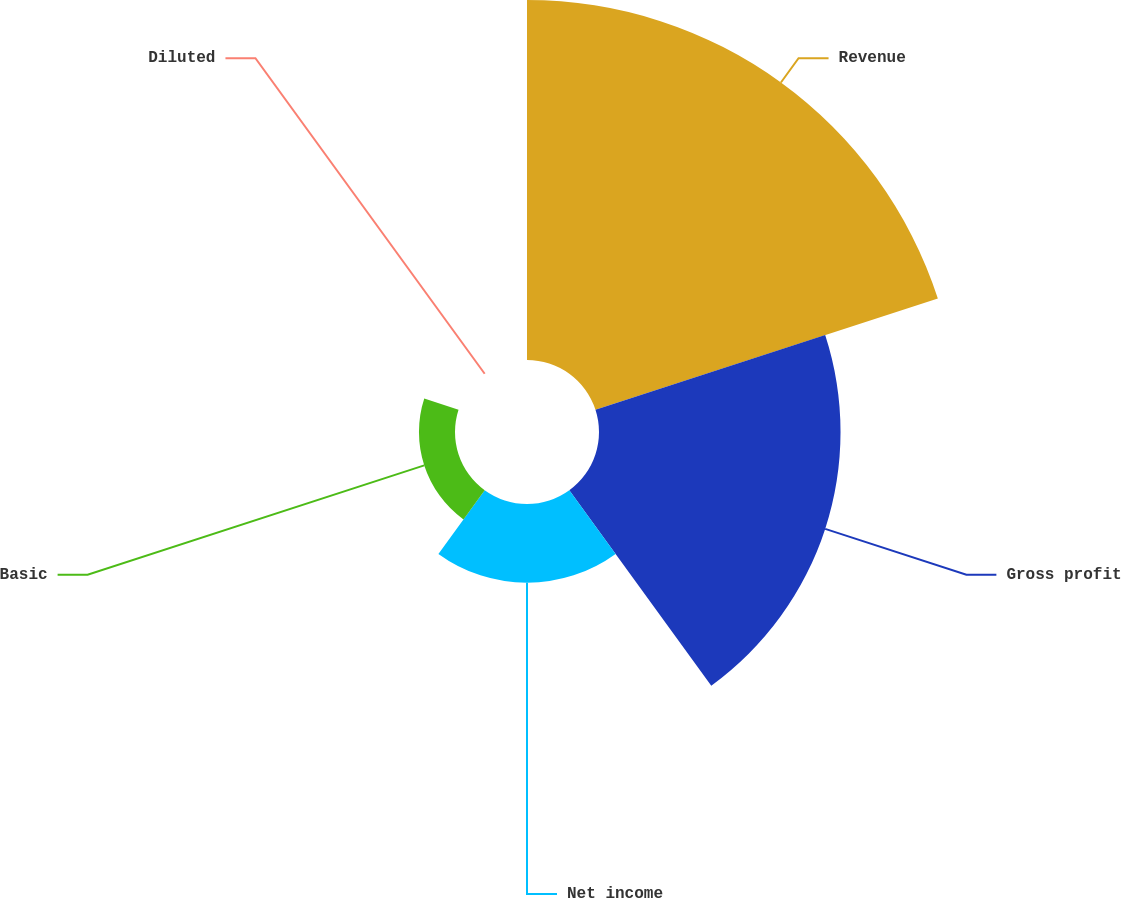Convert chart. <chart><loc_0><loc_0><loc_500><loc_500><pie_chart><fcel>Revenue<fcel>Gross profit<fcel>Net income<fcel>Basic<fcel>Diluted<nl><fcel>50.26%<fcel>33.72%<fcel>10.99%<fcel>5.03%<fcel>0.0%<nl></chart> 